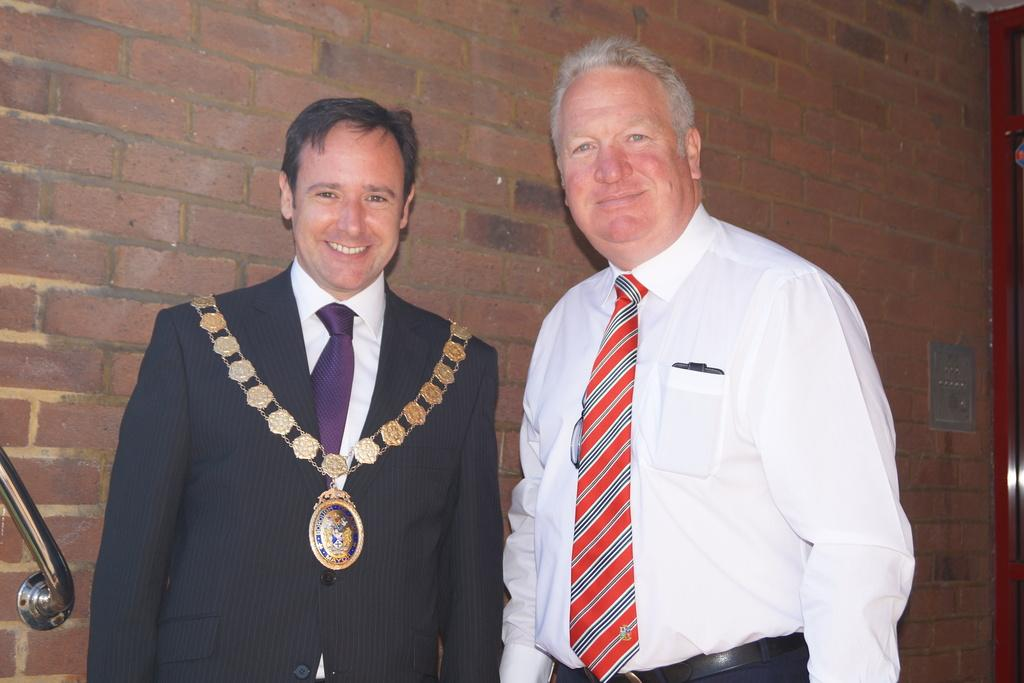How many people are in the image? There are two persons in the image. What are the two persons doing in the image? The two persons are standing and smiling. What can be seen in the background of the image? There is a wall made up of bricks in the background of the image. What type of balls are being played with by the two persons in the image? There are no balls present in the image; the two persons are simply standing and smiling. 